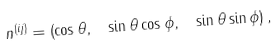<formula> <loc_0><loc_0><loc_500><loc_500>n ^ { ( i j ) } = \left ( \cos \theta , \text { } \sin \theta \cos \phi , \text { } \sin \theta \sin \phi \right ) ,</formula> 